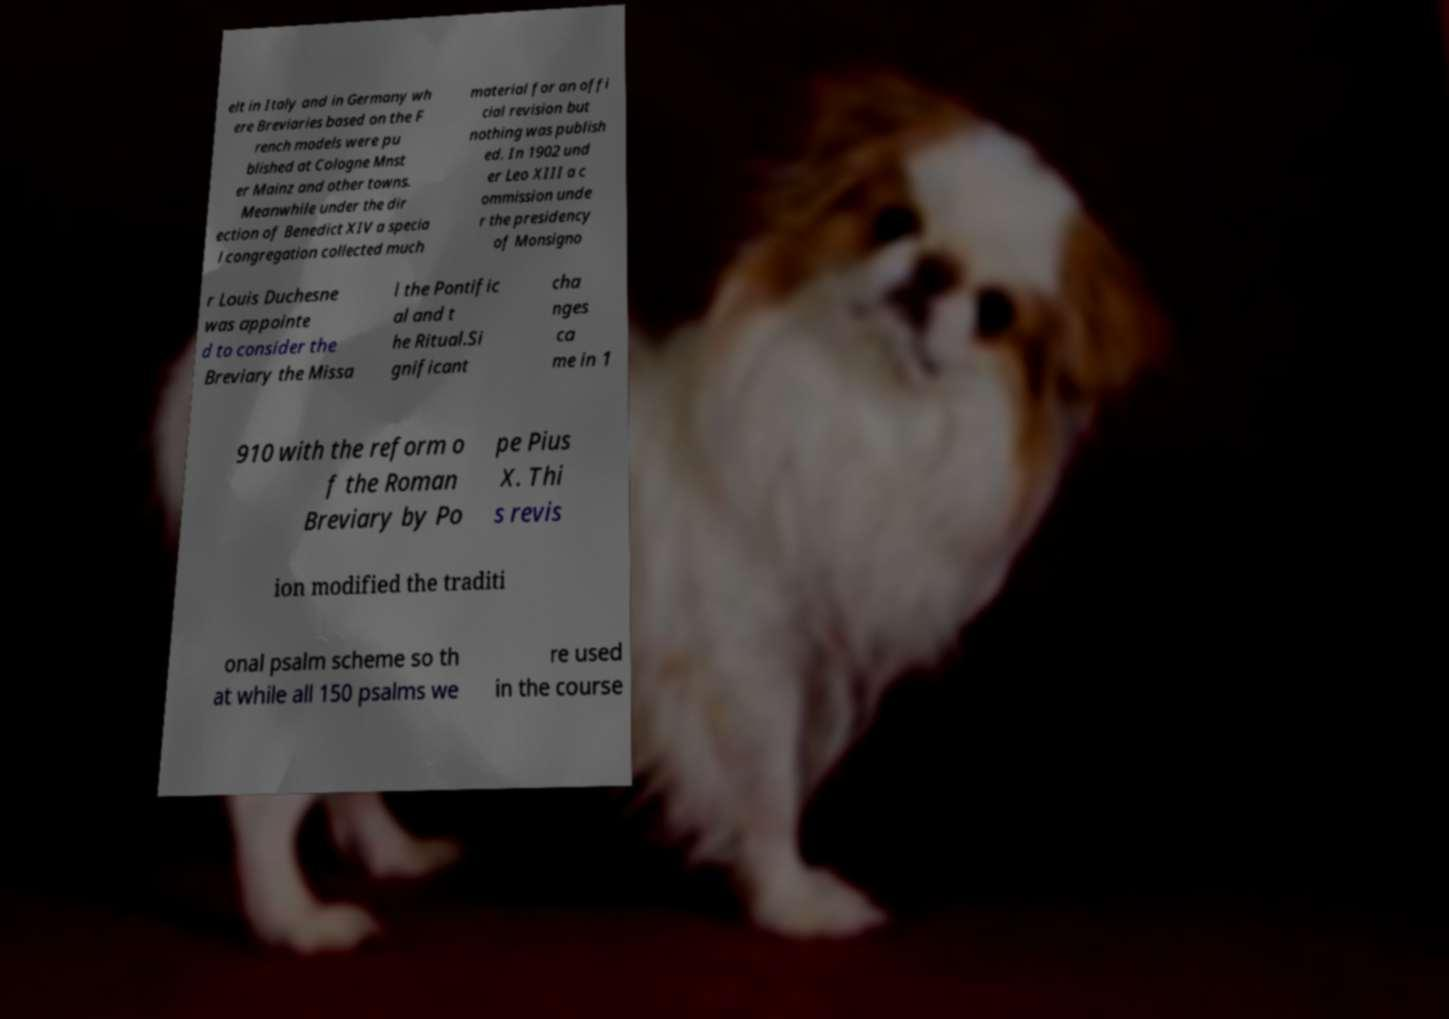Can you accurately transcribe the text from the provided image for me? elt in Italy and in Germany wh ere Breviaries based on the F rench models were pu blished at Cologne Mnst er Mainz and other towns. Meanwhile under the dir ection of Benedict XIV a specia l congregation collected much material for an offi cial revision but nothing was publish ed. In 1902 und er Leo XIII a c ommission unde r the presidency of Monsigno r Louis Duchesne was appointe d to consider the Breviary the Missa l the Pontific al and t he Ritual.Si gnificant cha nges ca me in 1 910 with the reform o f the Roman Breviary by Po pe Pius X. Thi s revis ion modified the traditi onal psalm scheme so th at while all 150 psalms we re used in the course 